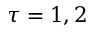Convert formula to latex. <formula><loc_0><loc_0><loc_500><loc_500>\tau = 1 , 2</formula> 